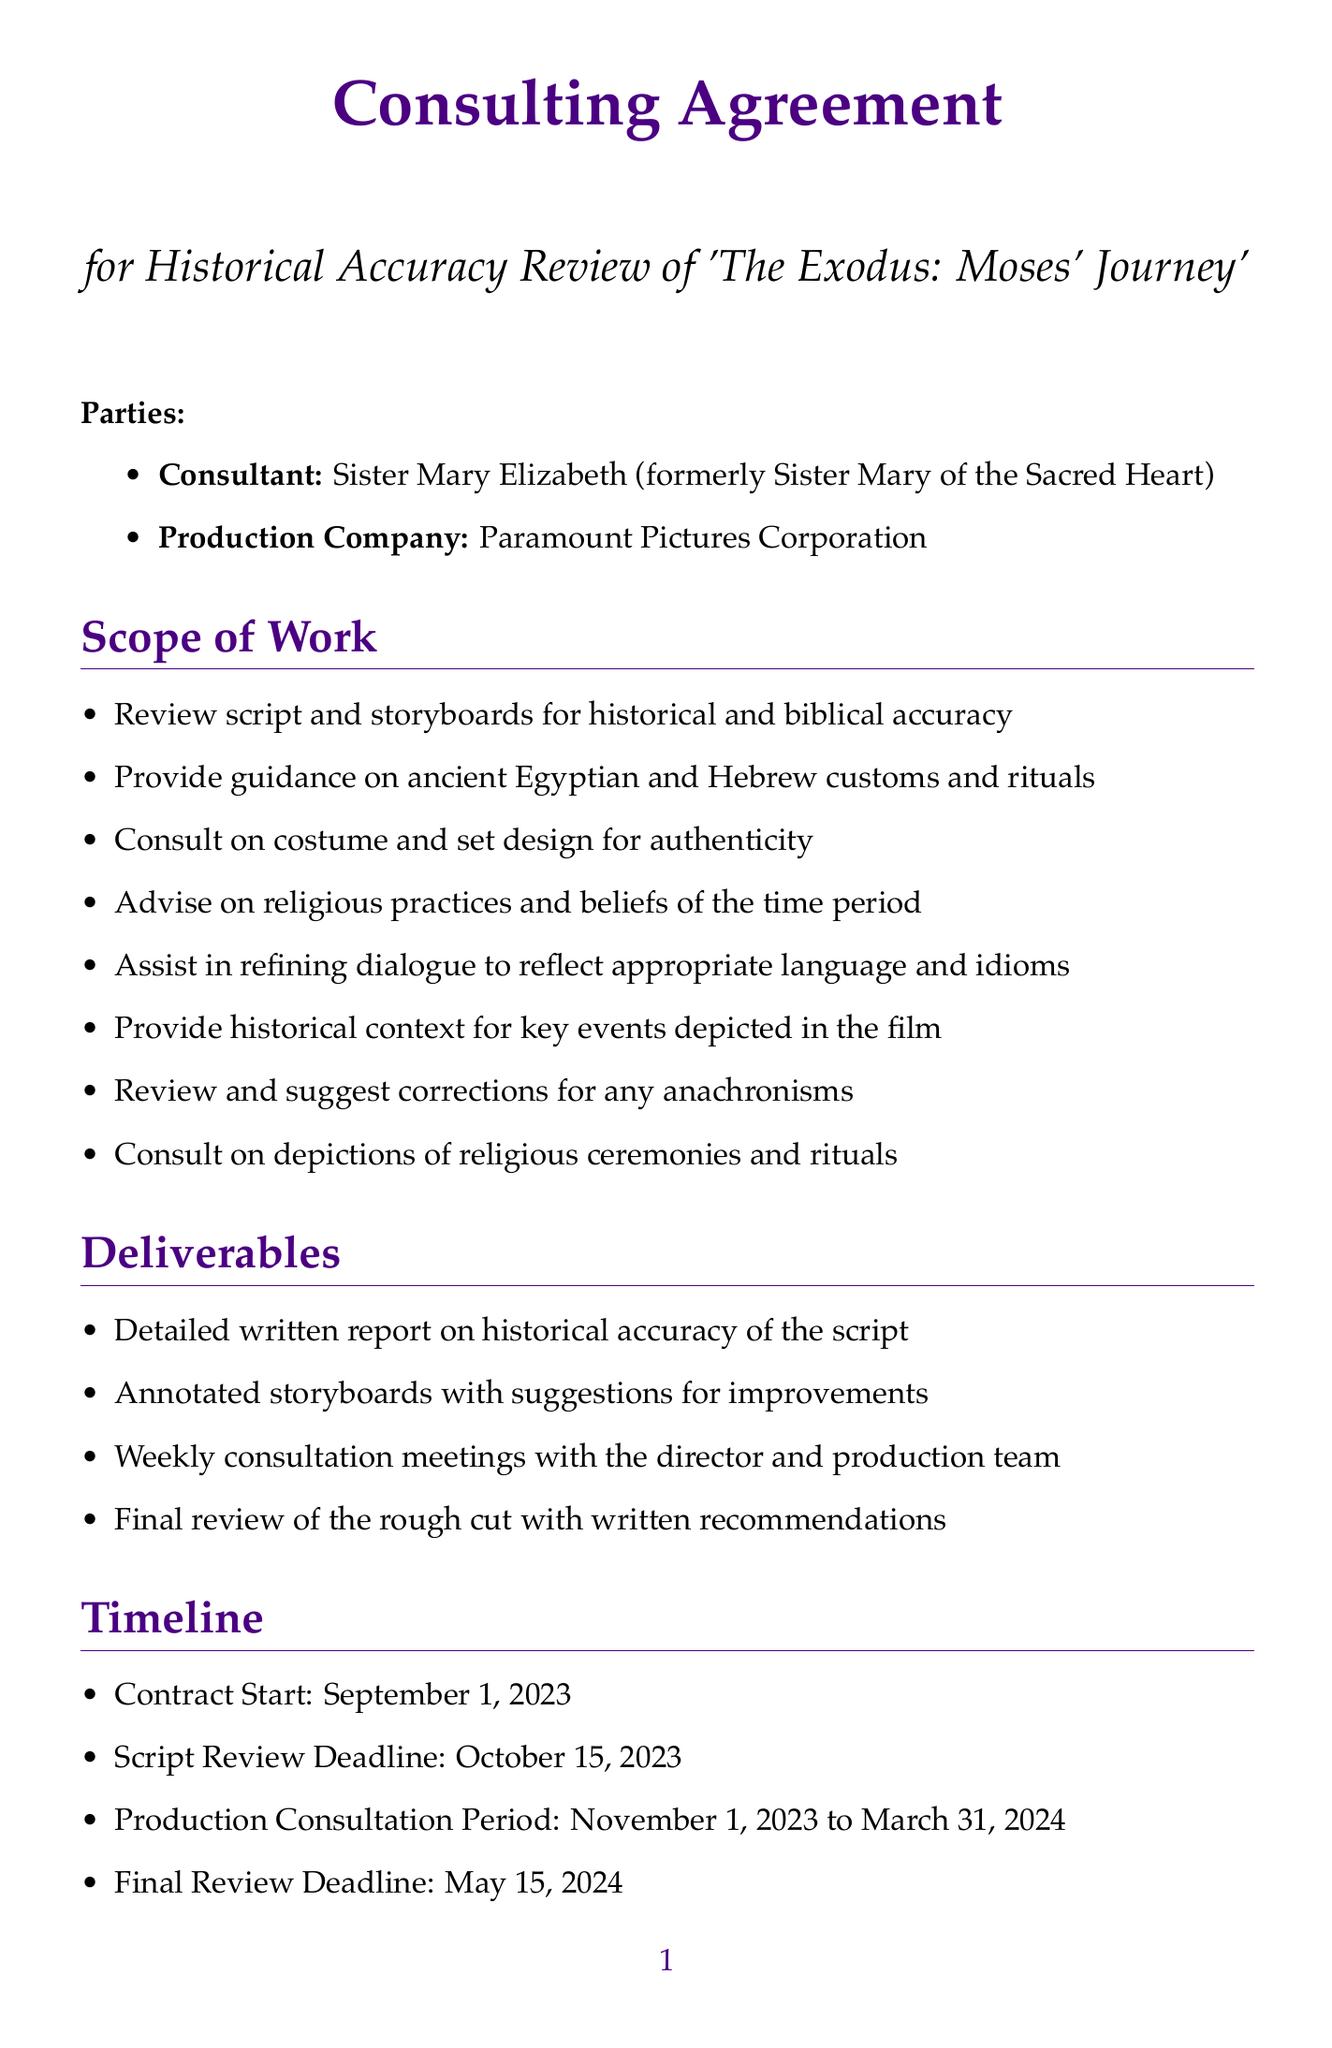What is the title of the consulting agreement? The title of the consulting agreement is stated clearly at the top of the document.
Answer: Consulting Agreement for Historical Accuracy Review of 'The Exodus: Moses' Journey' Who is the consultant? The document specifies the name of the consultant in the parties section.
Answer: Sister Mary Elizabeth (formerly Sister Mary of the Sacred Heart) When does the production consultation period start and end? The timeline section provides specific dates for the production consultation period.
Answer: November 1, 2023 to March 31, 2024 What is the fee for the initial script review? The fee structure outlines the cost for various services, including the initial script review fee.
Answer: $15,000 How long is the confidentiality duration? The confidentiality section mentions the duration of confidentiality after contract signing.
Answer: 5 years from contract signing What is the method for dispute resolution? The document outlines the method of resolving disputes in the dispute resolution section.
Answer: Binding arbitration What type of experience does the consultant have? The relevant experience section lists the qualifications and background of the consultant.
Answer: 15 years as a Benedictine nun What expenses are reimbursed? The expenses section specifies the types of costs that will be reimbursed by the production company.
Answer: Travel: Reimbursed at actual cost Who provides accommodation during the project? The expenses section states who is responsible for providing accommodation.
Answer: Provided by production company 